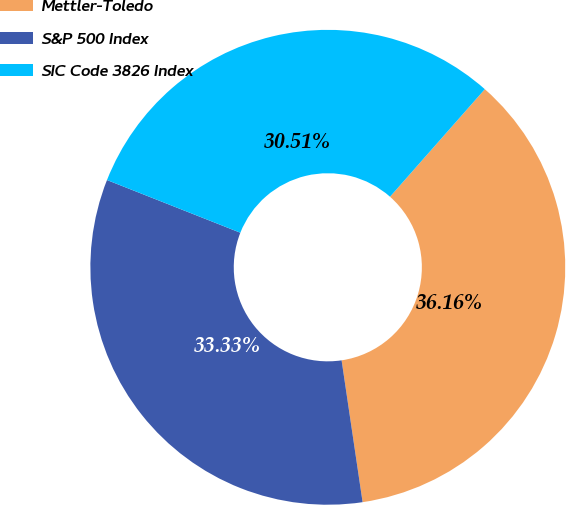<chart> <loc_0><loc_0><loc_500><loc_500><pie_chart><fcel>Mettler-Toledo<fcel>S&P 500 Index<fcel>SIC Code 3826 Index<nl><fcel>36.16%<fcel>33.33%<fcel>30.51%<nl></chart> 